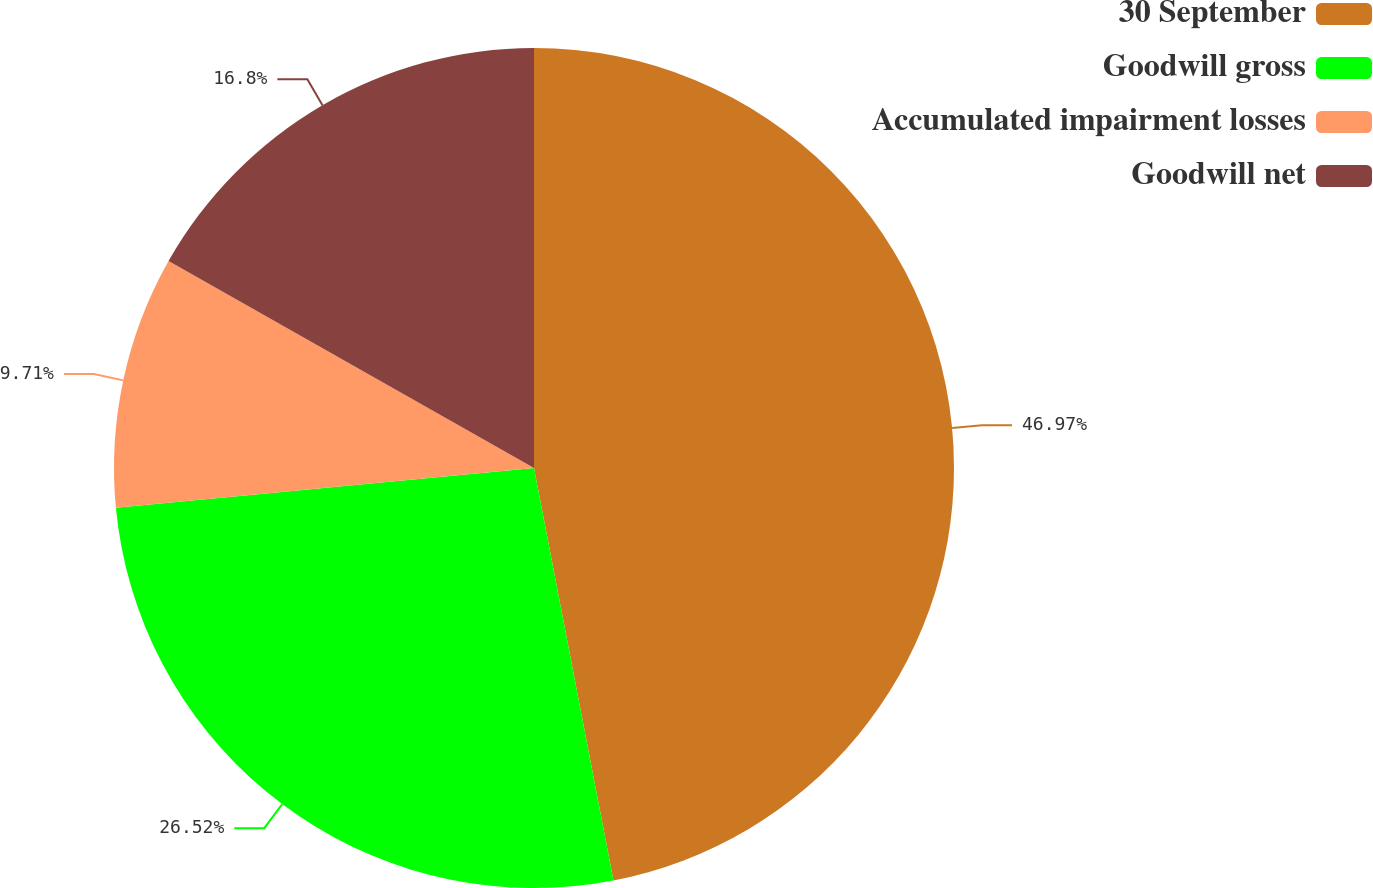Convert chart. <chart><loc_0><loc_0><loc_500><loc_500><pie_chart><fcel>30 September<fcel>Goodwill gross<fcel>Accumulated impairment losses<fcel>Goodwill net<nl><fcel>46.97%<fcel>26.52%<fcel>9.71%<fcel>16.8%<nl></chart> 